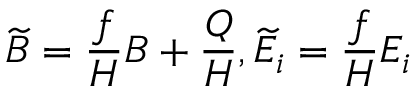<formula> <loc_0><loc_0><loc_500><loc_500>\widetilde { B } = \frac { f } { H } B + \frac { Q } { H } , \widetilde { E } _ { i } = \frac { f } { H } E _ { i }</formula> 